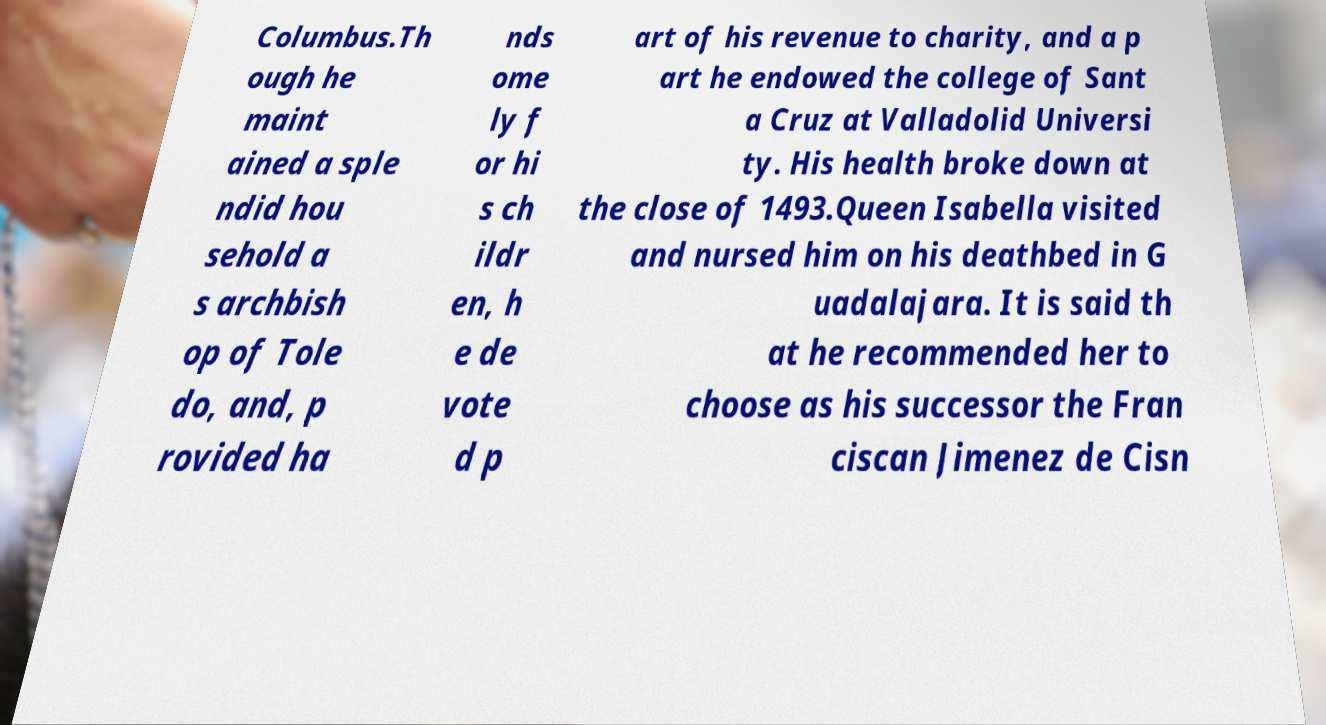Can you read and provide the text displayed in the image?This photo seems to have some interesting text. Can you extract and type it out for me? Columbus.Th ough he maint ained a sple ndid hou sehold a s archbish op of Tole do, and, p rovided ha nds ome ly f or hi s ch ildr en, h e de vote d p art of his revenue to charity, and a p art he endowed the college of Sant a Cruz at Valladolid Universi ty. His health broke down at the close of 1493.Queen Isabella visited and nursed him on his deathbed in G uadalajara. It is said th at he recommended her to choose as his successor the Fran ciscan Jimenez de Cisn 